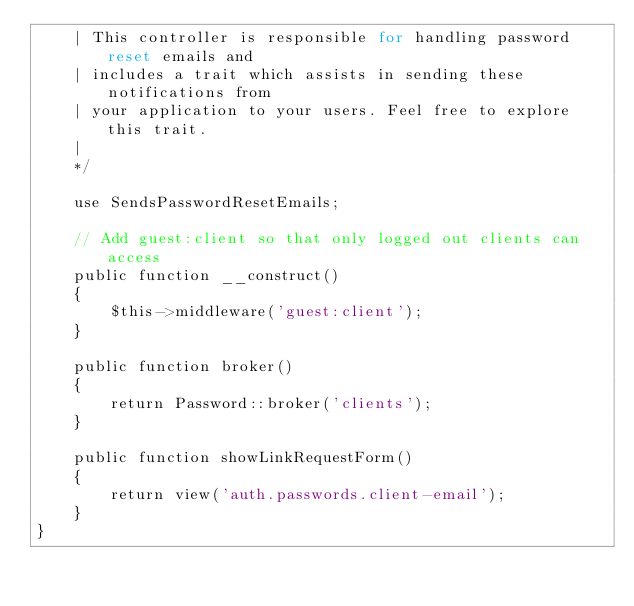Convert code to text. <code><loc_0><loc_0><loc_500><loc_500><_PHP_>    | This controller is responsible for handling password reset emails and
    | includes a trait which assists in sending these notifications from
    | your application to your users. Feel free to explore this trait.
    |
    */

    use SendsPasswordResetEmails;

    // Add guest:client so that only logged out clients can access
    public function __construct()
    {
        $this->middleware('guest:client');
    }

    public function broker()
    {
        return Password::broker('clients');
    }

    public function showLinkRequestForm()
    {
        return view('auth.passwords.client-email');
    }
}
</code> 